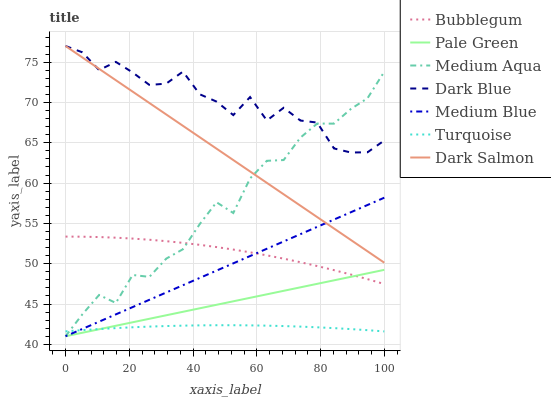Does Medium Blue have the minimum area under the curve?
Answer yes or no. No. Does Medium Blue have the maximum area under the curve?
Answer yes or no. No. Is Dark Salmon the smoothest?
Answer yes or no. No. Is Dark Salmon the roughest?
Answer yes or no. No. Does Dark Salmon have the lowest value?
Answer yes or no. No. Does Medium Blue have the highest value?
Answer yes or no. No. Is Medium Blue less than Dark Blue?
Answer yes or no. Yes. Is Bubblegum greater than Turquoise?
Answer yes or no. Yes. Does Medium Blue intersect Dark Blue?
Answer yes or no. No. 